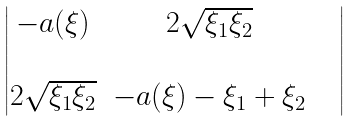Convert formula to latex. <formula><loc_0><loc_0><loc_500><loc_500>\begin{vmatrix} - a ( \xi ) & 2 \sqrt { \xi _ { 1 } \xi _ { 2 } } \\ & & & \\ 2 \sqrt { \xi _ { 1 } \xi _ { 2 } } & - a ( \xi ) - \xi _ { 1 } + \xi _ { 2 } \end{vmatrix}</formula> 